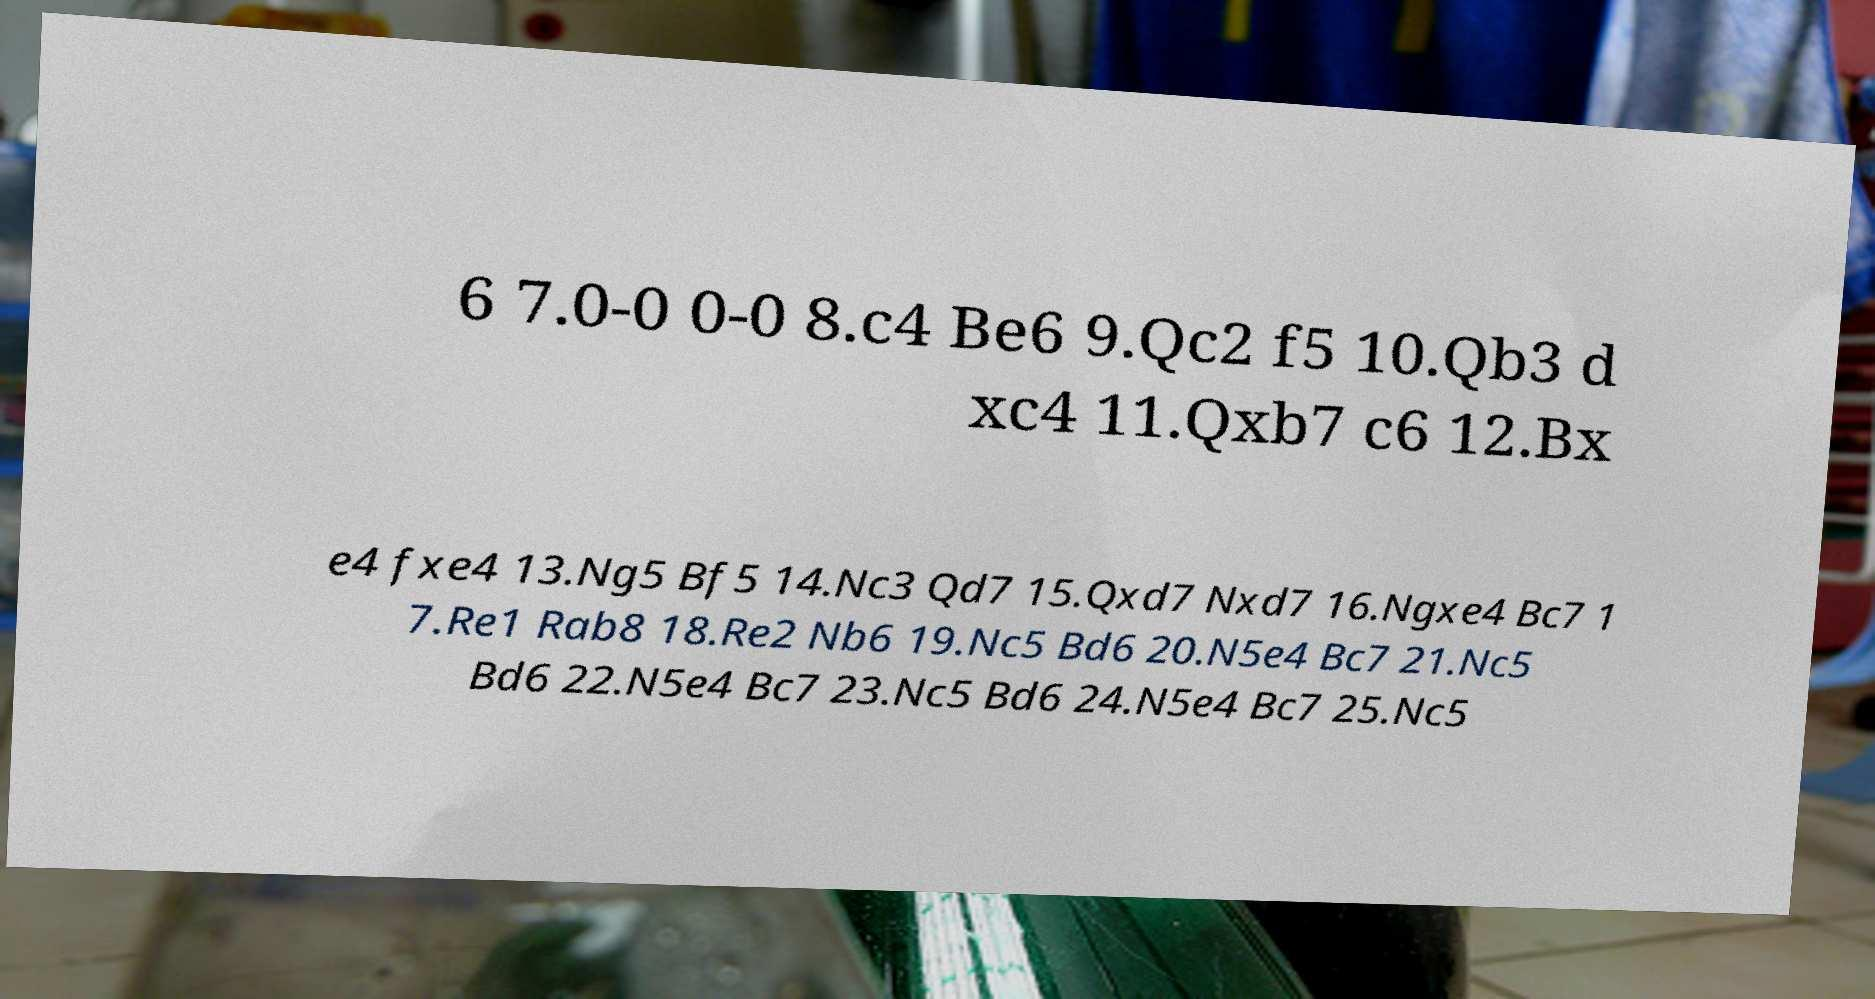Can you read and provide the text displayed in the image?This photo seems to have some interesting text. Can you extract and type it out for me? 6 7.0-0 0-0 8.c4 Be6 9.Qc2 f5 10.Qb3 d xc4 11.Qxb7 c6 12.Bx e4 fxe4 13.Ng5 Bf5 14.Nc3 Qd7 15.Qxd7 Nxd7 16.Ngxe4 Bc7 1 7.Re1 Rab8 18.Re2 Nb6 19.Nc5 Bd6 20.N5e4 Bc7 21.Nc5 Bd6 22.N5e4 Bc7 23.Nc5 Bd6 24.N5e4 Bc7 25.Nc5 